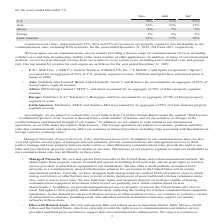According to American Tower Corporation's financial document, What was the approximate percentage of revenue in the company's property segments were attributable to their communication sites in 2018? According to the financial document, 96%. The relevant text states: "Communications Sites. Approximately 95%, 96% and 97% of revenue in our property segments was attributable to our..." Also, How many percent of total revenue in 2019 was accounted for by property segments in the U.S.? According to the financial document, 55%. The relevant text states: "U.S. 55% 51% 55%..." Also, How many percent of total revenue in 2018 was accounted for by property segments in Asia? According to the financial document, 21%. The relevant text states: "Asia 16% 21% 17%..." Also, can you calculate: What is the sum of the three highest contributing property segments in 2017? Based on the calculation: 55%+18%+17%, the result is 90 (percentage). This is based on the information: "2019 2018 2017 2019 2018 2017 U.S. 55% 51% 55%..." The key data points involved are: 17, 18, 55. Also, can you calculate: What is the sum of the three least contributing property segments in 2019? Based on the calculation: 2%+8%+16%, the result is 26 (percentage). This is based on the information: "Asia 16% 21% 17% 2019 2018 2017 2019 2018 2017..." The key data points involved are: 16, 8. Also, can you calculate: What was the change in the percentage of total revenue in U.S. between 2018 and 2019? Based on the calculation: 55%-51%, the result is 4 (percentage). This is based on the information: "U.S. 55% 51% 55% U.S. 55% 51% 55%..." The key data points involved are: 51, 55. 